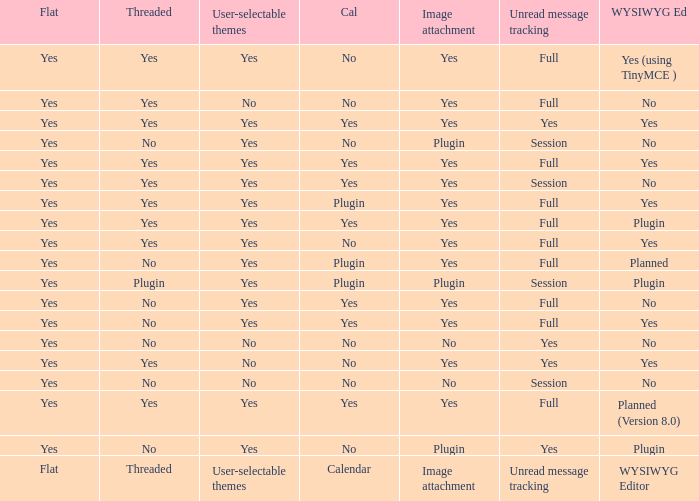Which Calendar has a User-selectable themes of user-selectable themes? Calendar. 